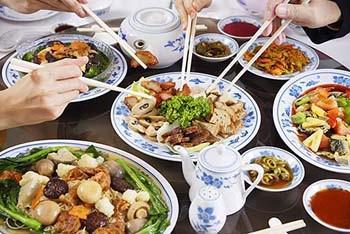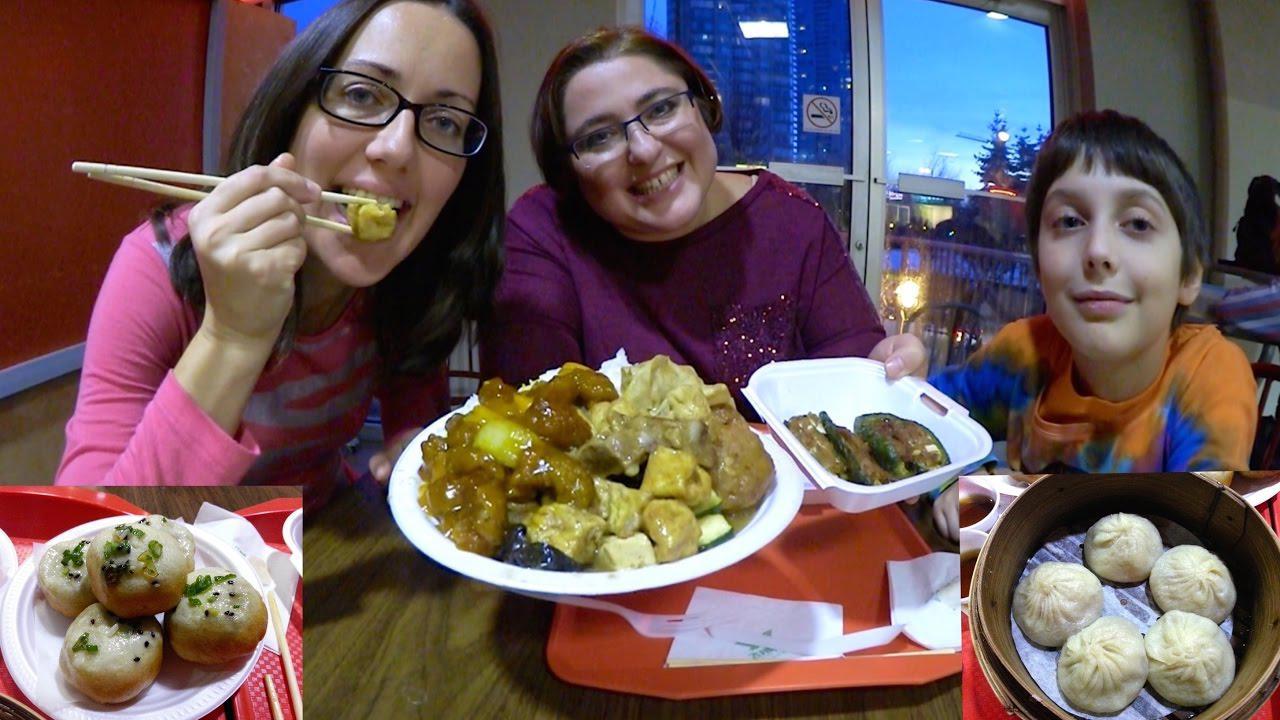The first image is the image on the left, the second image is the image on the right. Analyze the images presented: Is the assertion "In one of the images, four people are about to grab food from one plate, each using chop sticks." valid? Answer yes or no. Yes. The first image is the image on the left, the second image is the image on the right. Assess this claim about the two images: "People are holding chopsticks in both images.". Correct or not? Answer yes or no. Yes. 